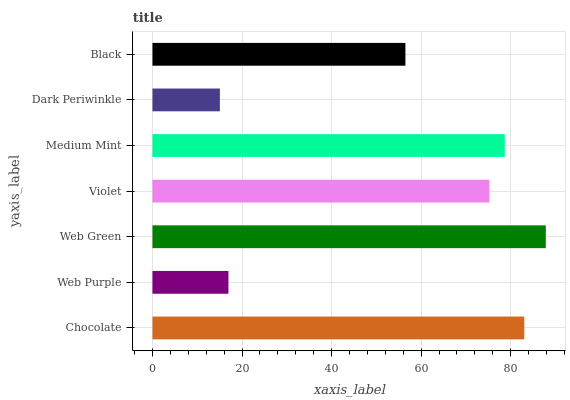Is Dark Periwinkle the minimum?
Answer yes or no. Yes. Is Web Green the maximum?
Answer yes or no. Yes. Is Web Purple the minimum?
Answer yes or no. No. Is Web Purple the maximum?
Answer yes or no. No. Is Chocolate greater than Web Purple?
Answer yes or no. Yes. Is Web Purple less than Chocolate?
Answer yes or no. Yes. Is Web Purple greater than Chocolate?
Answer yes or no. No. Is Chocolate less than Web Purple?
Answer yes or no. No. Is Violet the high median?
Answer yes or no. Yes. Is Violet the low median?
Answer yes or no. Yes. Is Chocolate the high median?
Answer yes or no. No. Is Web Purple the low median?
Answer yes or no. No. 